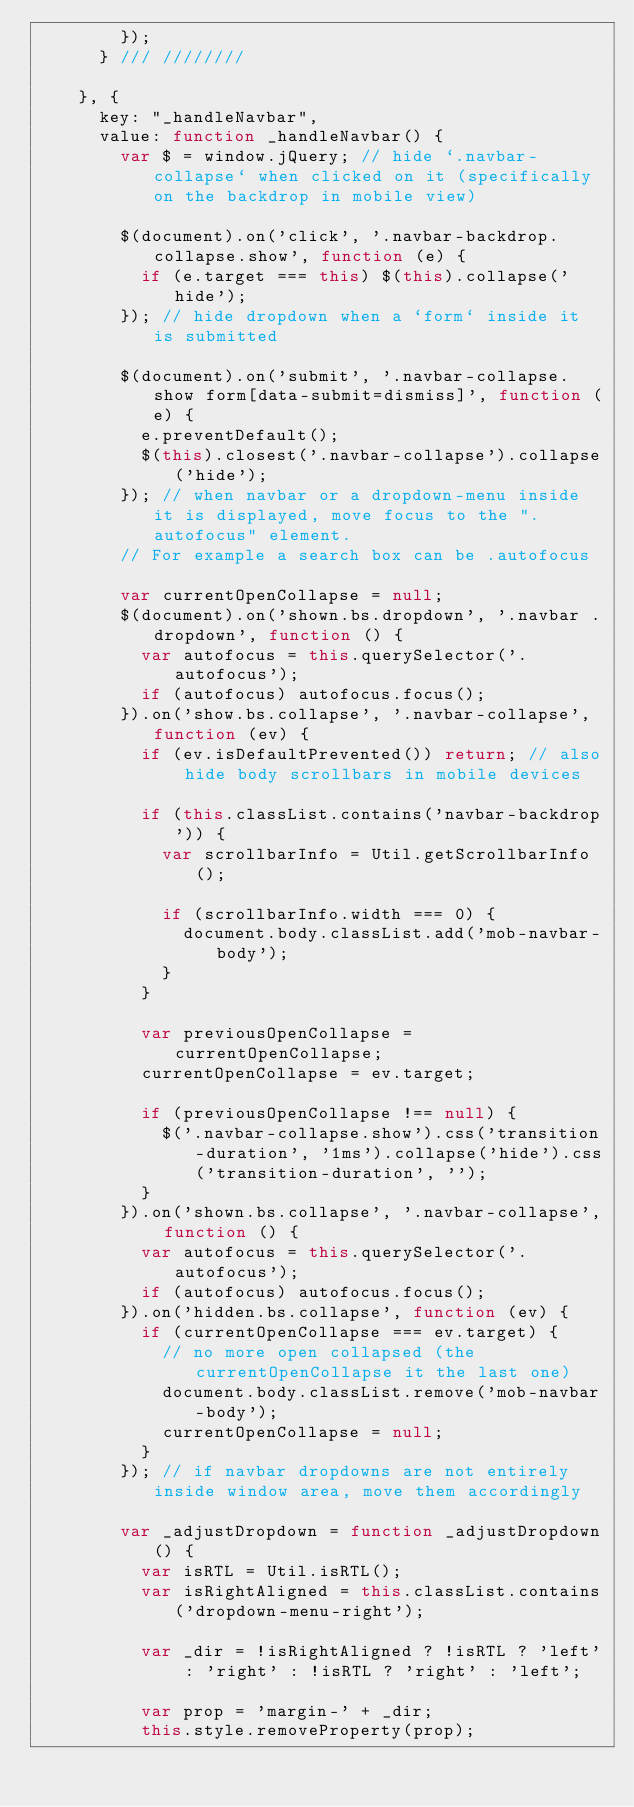Convert code to text. <code><loc_0><loc_0><loc_500><loc_500><_JavaScript_>        });
      } /// ////////

    }, {
      key: "_handleNavbar",
      value: function _handleNavbar() {
        var $ = window.jQuery; // hide `.navbar-collapse` when clicked on it (specifically on the backdrop in mobile view)

        $(document).on('click', '.navbar-backdrop.collapse.show', function (e) {
          if (e.target === this) $(this).collapse('hide');
        }); // hide dropdown when a `form` inside it is submitted

        $(document).on('submit', '.navbar-collapse.show form[data-submit=dismiss]', function (e) {
          e.preventDefault();
          $(this).closest('.navbar-collapse').collapse('hide');
        }); // when navbar or a dropdown-menu inside it is displayed, move focus to the ".autofocus" element.
        // For example a search box can be .autofocus

        var currentOpenCollapse = null;
        $(document).on('shown.bs.dropdown', '.navbar .dropdown', function () {
          var autofocus = this.querySelector('.autofocus');
          if (autofocus) autofocus.focus();
        }).on('show.bs.collapse', '.navbar-collapse', function (ev) {
          if (ev.isDefaultPrevented()) return; // also hide body scrollbars in mobile devices

          if (this.classList.contains('navbar-backdrop')) {
            var scrollbarInfo = Util.getScrollbarInfo();

            if (scrollbarInfo.width === 0) {
              document.body.classList.add('mob-navbar-body');
            }
          }

          var previousOpenCollapse = currentOpenCollapse;
          currentOpenCollapse = ev.target;

          if (previousOpenCollapse !== null) {
            $('.navbar-collapse.show').css('transition-duration', '1ms').collapse('hide').css('transition-duration', '');
          }
        }).on('shown.bs.collapse', '.navbar-collapse', function () {
          var autofocus = this.querySelector('.autofocus');
          if (autofocus) autofocus.focus();
        }).on('hidden.bs.collapse', function (ev) {
          if (currentOpenCollapse === ev.target) {
            // no more open collapsed (the currentOpenCollapse it the last one)
            document.body.classList.remove('mob-navbar-body');
            currentOpenCollapse = null;
          }
        }); // if navbar dropdowns are not entirely inside window area, move them accordingly

        var _adjustDropdown = function _adjustDropdown() {
          var isRTL = Util.isRTL();
          var isRightAligned = this.classList.contains('dropdown-menu-right');

          var _dir = !isRightAligned ? !isRTL ? 'left' : 'right' : !isRTL ? 'right' : 'left';

          var prop = 'margin-' + _dir;
          this.style.removeProperty(prop);</code> 